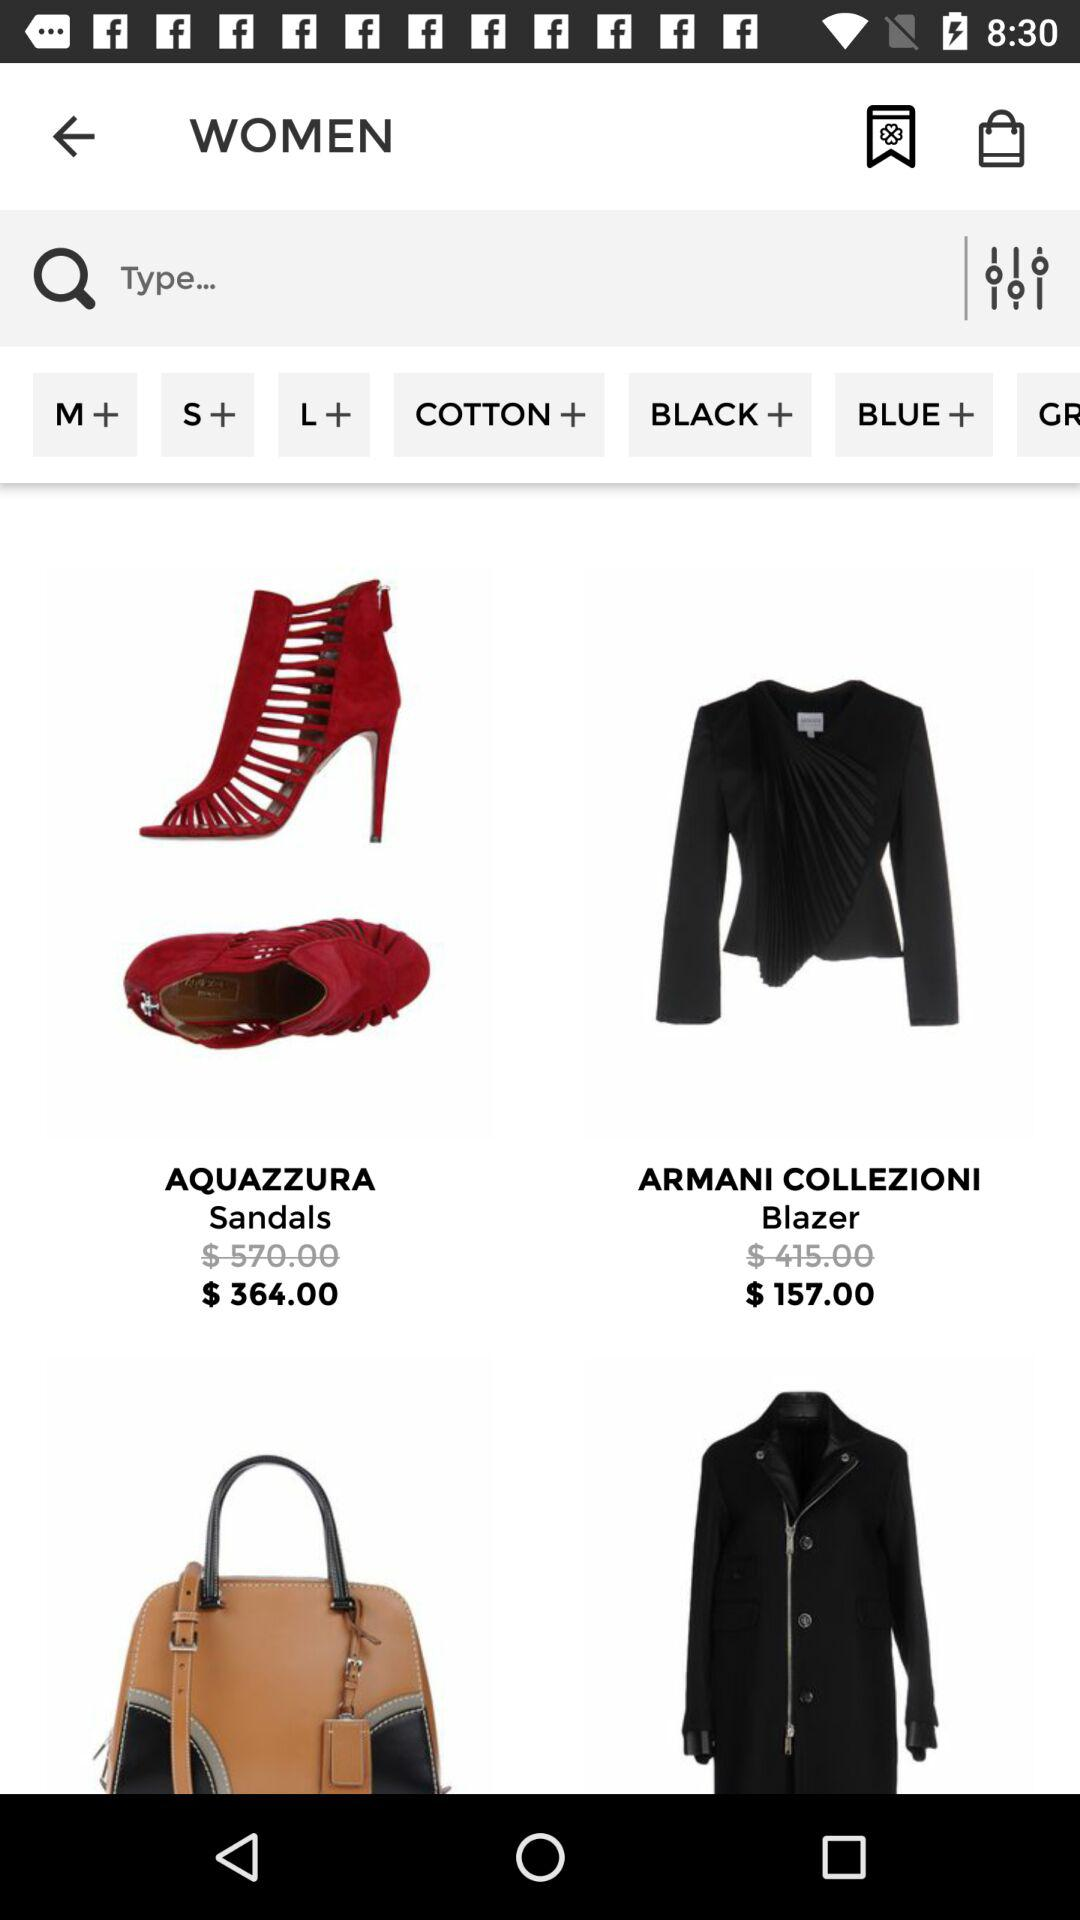What is the currency of the price? The currency is $. 